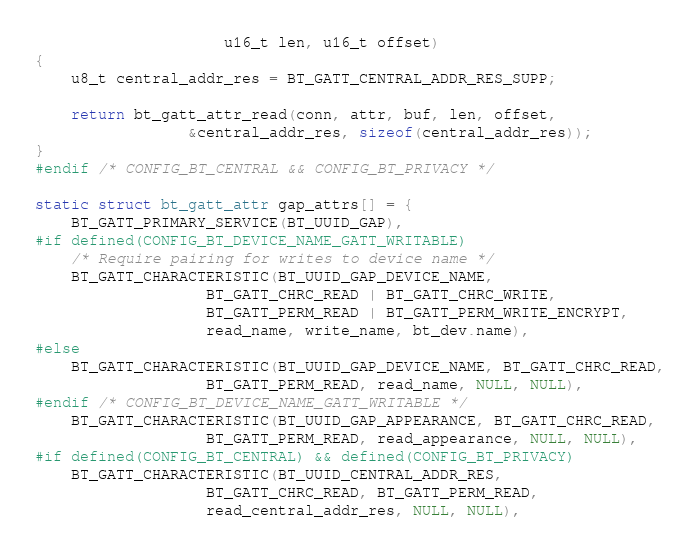<code> <loc_0><loc_0><loc_500><loc_500><_C_>				     u16_t len, u16_t offset)
{
	u8_t central_addr_res = BT_GATT_CENTRAL_ADDR_RES_SUPP;

	return bt_gatt_attr_read(conn, attr, buf, len, offset,
				 &central_addr_res, sizeof(central_addr_res));
}
#endif /* CONFIG_BT_CENTRAL && CONFIG_BT_PRIVACY */

static struct bt_gatt_attr gap_attrs[] = {
	BT_GATT_PRIMARY_SERVICE(BT_UUID_GAP),
#if defined(CONFIG_BT_DEVICE_NAME_GATT_WRITABLE)
	/* Require pairing for writes to device name */
	BT_GATT_CHARACTERISTIC(BT_UUID_GAP_DEVICE_NAME,
			       BT_GATT_CHRC_READ | BT_GATT_CHRC_WRITE,
			       BT_GATT_PERM_READ | BT_GATT_PERM_WRITE_ENCRYPT,
			       read_name, write_name, bt_dev.name),
#else
	BT_GATT_CHARACTERISTIC(BT_UUID_GAP_DEVICE_NAME, BT_GATT_CHRC_READ,
			       BT_GATT_PERM_READ, read_name, NULL, NULL),
#endif /* CONFIG_BT_DEVICE_NAME_GATT_WRITABLE */
	BT_GATT_CHARACTERISTIC(BT_UUID_GAP_APPEARANCE, BT_GATT_CHRC_READ,
			       BT_GATT_PERM_READ, read_appearance, NULL, NULL),
#if defined(CONFIG_BT_CENTRAL) && defined(CONFIG_BT_PRIVACY)
	BT_GATT_CHARACTERISTIC(BT_UUID_CENTRAL_ADDR_RES,
			       BT_GATT_CHRC_READ, BT_GATT_PERM_READ,
			       read_central_addr_res, NULL, NULL),</code> 